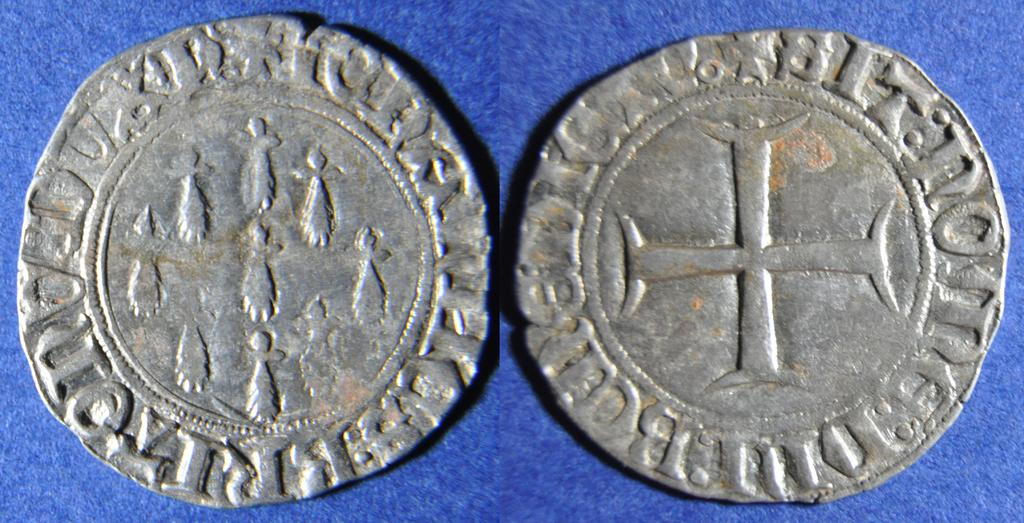How many coins are visible in the image? There are 2 coins in the image. What is the color of the surface on which the coins are placed? The coins are on a blue color surface. What type of insurance policy is being discussed in the image? There is no reference to any insurance policy or discussion in the image; it only features coins on a blue surface. How many cherries are visible in the image? There are no cherries present in the image. 